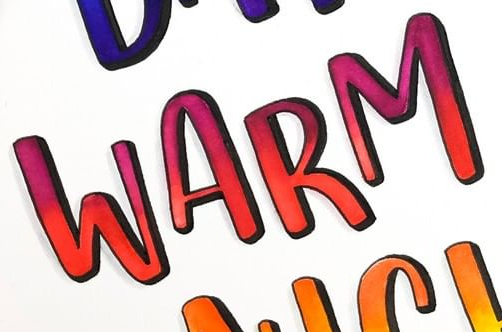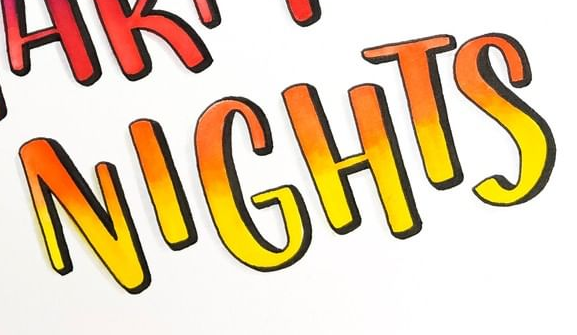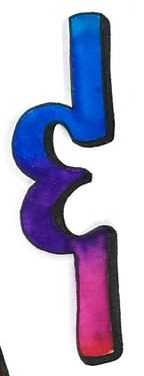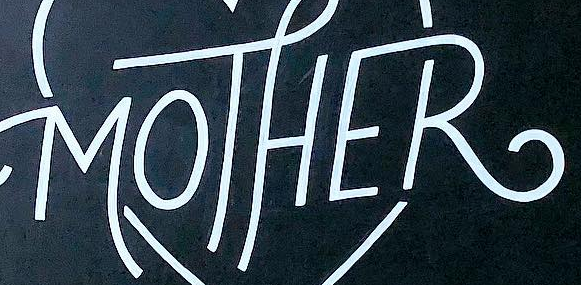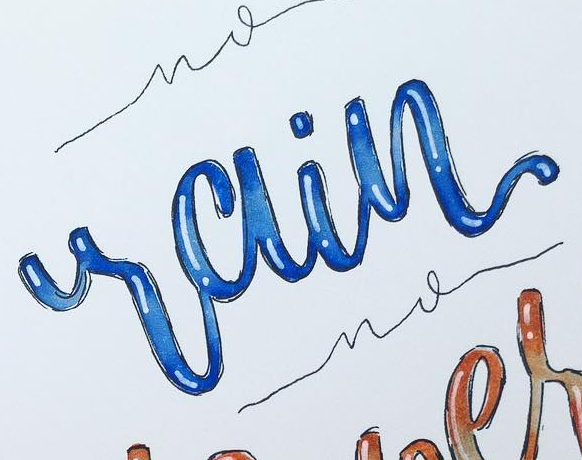Identify the words shown in these images in order, separated by a semicolon. WARM; NIGHTS; &; MOTHER; rain 